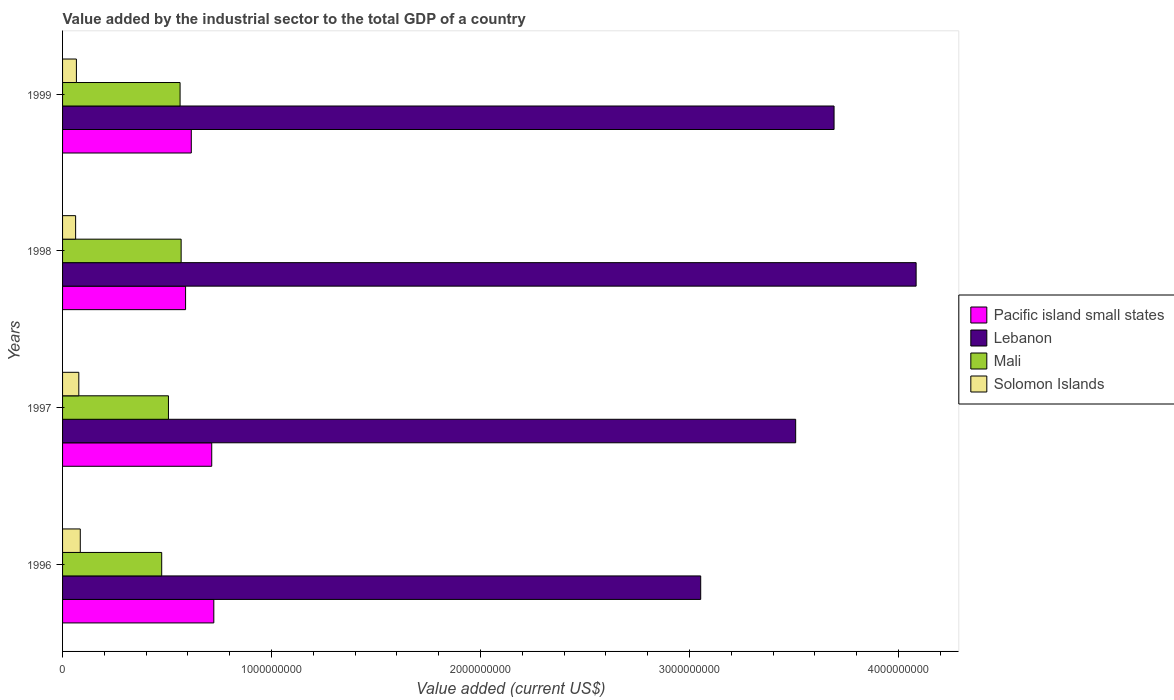Are the number of bars per tick equal to the number of legend labels?
Make the answer very short. Yes. How many bars are there on the 2nd tick from the bottom?
Offer a very short reply. 4. What is the value added by the industrial sector to the total GDP in Mali in 1996?
Your response must be concise. 4.74e+08. Across all years, what is the maximum value added by the industrial sector to the total GDP in Pacific island small states?
Keep it short and to the point. 7.24e+08. Across all years, what is the minimum value added by the industrial sector to the total GDP in Solomon Islands?
Your response must be concise. 6.25e+07. In which year was the value added by the industrial sector to the total GDP in Pacific island small states maximum?
Give a very brief answer. 1996. What is the total value added by the industrial sector to the total GDP in Solomon Islands in the graph?
Provide a succinct answer. 2.91e+08. What is the difference between the value added by the industrial sector to the total GDP in Mali in 1996 and that in 1998?
Offer a terse response. -9.30e+07. What is the difference between the value added by the industrial sector to the total GDP in Pacific island small states in 1996 and the value added by the industrial sector to the total GDP in Mali in 1999?
Your answer should be compact. 1.61e+08. What is the average value added by the industrial sector to the total GDP in Pacific island small states per year?
Keep it short and to the point. 6.61e+08. In the year 1999, what is the difference between the value added by the industrial sector to the total GDP in Mali and value added by the industrial sector to the total GDP in Solomon Islands?
Keep it short and to the point. 4.96e+08. In how many years, is the value added by the industrial sector to the total GDP in Mali greater than 2400000000 US$?
Make the answer very short. 0. What is the ratio of the value added by the industrial sector to the total GDP in Solomon Islands in 1996 to that in 1998?
Your response must be concise. 1.36. What is the difference between the highest and the second highest value added by the industrial sector to the total GDP in Pacific island small states?
Provide a short and direct response. 9.95e+06. What is the difference between the highest and the lowest value added by the industrial sector to the total GDP in Pacific island small states?
Your response must be concise. 1.35e+08. In how many years, is the value added by the industrial sector to the total GDP in Lebanon greater than the average value added by the industrial sector to the total GDP in Lebanon taken over all years?
Offer a terse response. 2. What does the 3rd bar from the top in 1999 represents?
Ensure brevity in your answer.  Lebanon. What does the 3rd bar from the bottom in 1996 represents?
Offer a very short reply. Mali. Are all the bars in the graph horizontal?
Make the answer very short. Yes. How many years are there in the graph?
Offer a terse response. 4. Does the graph contain any zero values?
Offer a terse response. No. Does the graph contain grids?
Your response must be concise. No. Where does the legend appear in the graph?
Ensure brevity in your answer.  Center right. How many legend labels are there?
Provide a short and direct response. 4. What is the title of the graph?
Ensure brevity in your answer.  Value added by the industrial sector to the total GDP of a country. Does "South Sudan" appear as one of the legend labels in the graph?
Your response must be concise. No. What is the label or title of the X-axis?
Offer a terse response. Value added (current US$). What is the label or title of the Y-axis?
Give a very brief answer. Years. What is the Value added (current US$) of Pacific island small states in 1996?
Offer a very short reply. 7.24e+08. What is the Value added (current US$) in Lebanon in 1996?
Your response must be concise. 3.05e+09. What is the Value added (current US$) in Mali in 1996?
Provide a short and direct response. 4.74e+08. What is the Value added (current US$) in Solomon Islands in 1996?
Your response must be concise. 8.48e+07. What is the Value added (current US$) in Pacific island small states in 1997?
Offer a terse response. 7.14e+08. What is the Value added (current US$) in Lebanon in 1997?
Ensure brevity in your answer.  3.51e+09. What is the Value added (current US$) in Mali in 1997?
Ensure brevity in your answer.  5.07e+08. What is the Value added (current US$) of Solomon Islands in 1997?
Make the answer very short. 7.77e+07. What is the Value added (current US$) in Pacific island small states in 1998?
Offer a very short reply. 5.89e+08. What is the Value added (current US$) in Lebanon in 1998?
Offer a terse response. 4.08e+09. What is the Value added (current US$) in Mali in 1998?
Keep it short and to the point. 5.67e+08. What is the Value added (current US$) in Solomon Islands in 1998?
Give a very brief answer. 6.25e+07. What is the Value added (current US$) in Pacific island small states in 1999?
Provide a short and direct response. 6.16e+08. What is the Value added (current US$) of Lebanon in 1999?
Your answer should be very brief. 3.69e+09. What is the Value added (current US$) in Mali in 1999?
Ensure brevity in your answer.  5.62e+08. What is the Value added (current US$) of Solomon Islands in 1999?
Offer a very short reply. 6.63e+07. Across all years, what is the maximum Value added (current US$) of Pacific island small states?
Offer a very short reply. 7.24e+08. Across all years, what is the maximum Value added (current US$) in Lebanon?
Give a very brief answer. 4.08e+09. Across all years, what is the maximum Value added (current US$) of Mali?
Offer a very short reply. 5.67e+08. Across all years, what is the maximum Value added (current US$) of Solomon Islands?
Provide a short and direct response. 8.48e+07. Across all years, what is the minimum Value added (current US$) of Pacific island small states?
Ensure brevity in your answer.  5.89e+08. Across all years, what is the minimum Value added (current US$) of Lebanon?
Offer a very short reply. 3.05e+09. Across all years, what is the minimum Value added (current US$) in Mali?
Make the answer very short. 4.74e+08. Across all years, what is the minimum Value added (current US$) in Solomon Islands?
Provide a succinct answer. 6.25e+07. What is the total Value added (current US$) of Pacific island small states in the graph?
Offer a very short reply. 2.64e+09. What is the total Value added (current US$) of Lebanon in the graph?
Provide a succinct answer. 1.43e+1. What is the total Value added (current US$) of Mali in the graph?
Ensure brevity in your answer.  2.11e+09. What is the total Value added (current US$) of Solomon Islands in the graph?
Make the answer very short. 2.91e+08. What is the difference between the Value added (current US$) of Pacific island small states in 1996 and that in 1997?
Provide a short and direct response. 9.95e+06. What is the difference between the Value added (current US$) in Lebanon in 1996 and that in 1997?
Give a very brief answer. -4.54e+08. What is the difference between the Value added (current US$) in Mali in 1996 and that in 1997?
Provide a short and direct response. -3.23e+07. What is the difference between the Value added (current US$) in Solomon Islands in 1996 and that in 1997?
Your answer should be very brief. 7.07e+06. What is the difference between the Value added (current US$) in Pacific island small states in 1996 and that in 1998?
Provide a succinct answer. 1.35e+08. What is the difference between the Value added (current US$) of Lebanon in 1996 and that in 1998?
Provide a short and direct response. -1.03e+09. What is the difference between the Value added (current US$) in Mali in 1996 and that in 1998?
Provide a short and direct response. -9.30e+07. What is the difference between the Value added (current US$) of Solomon Islands in 1996 and that in 1998?
Provide a succinct answer. 2.23e+07. What is the difference between the Value added (current US$) of Pacific island small states in 1996 and that in 1999?
Ensure brevity in your answer.  1.08e+08. What is the difference between the Value added (current US$) of Lebanon in 1996 and that in 1999?
Provide a short and direct response. -6.38e+08. What is the difference between the Value added (current US$) in Mali in 1996 and that in 1999?
Provide a succinct answer. -8.79e+07. What is the difference between the Value added (current US$) in Solomon Islands in 1996 and that in 1999?
Keep it short and to the point. 1.85e+07. What is the difference between the Value added (current US$) in Pacific island small states in 1997 and that in 1998?
Your response must be concise. 1.25e+08. What is the difference between the Value added (current US$) of Lebanon in 1997 and that in 1998?
Provide a succinct answer. -5.76e+08. What is the difference between the Value added (current US$) in Mali in 1997 and that in 1998?
Your answer should be compact. -6.07e+07. What is the difference between the Value added (current US$) of Solomon Islands in 1997 and that in 1998?
Provide a short and direct response. 1.53e+07. What is the difference between the Value added (current US$) of Pacific island small states in 1997 and that in 1999?
Make the answer very short. 9.78e+07. What is the difference between the Value added (current US$) in Lebanon in 1997 and that in 1999?
Ensure brevity in your answer.  -1.84e+08. What is the difference between the Value added (current US$) of Mali in 1997 and that in 1999?
Keep it short and to the point. -5.57e+07. What is the difference between the Value added (current US$) of Solomon Islands in 1997 and that in 1999?
Give a very brief answer. 1.15e+07. What is the difference between the Value added (current US$) of Pacific island small states in 1998 and that in 1999?
Make the answer very short. -2.74e+07. What is the difference between the Value added (current US$) of Lebanon in 1998 and that in 1999?
Make the answer very short. 3.93e+08. What is the difference between the Value added (current US$) in Mali in 1998 and that in 1999?
Make the answer very short. 5.05e+06. What is the difference between the Value added (current US$) of Solomon Islands in 1998 and that in 1999?
Your answer should be very brief. -3.80e+06. What is the difference between the Value added (current US$) of Pacific island small states in 1996 and the Value added (current US$) of Lebanon in 1997?
Your answer should be very brief. -2.78e+09. What is the difference between the Value added (current US$) of Pacific island small states in 1996 and the Value added (current US$) of Mali in 1997?
Your answer should be very brief. 2.17e+08. What is the difference between the Value added (current US$) of Pacific island small states in 1996 and the Value added (current US$) of Solomon Islands in 1997?
Make the answer very short. 6.46e+08. What is the difference between the Value added (current US$) of Lebanon in 1996 and the Value added (current US$) of Mali in 1997?
Keep it short and to the point. 2.55e+09. What is the difference between the Value added (current US$) of Lebanon in 1996 and the Value added (current US$) of Solomon Islands in 1997?
Offer a terse response. 2.98e+09. What is the difference between the Value added (current US$) of Mali in 1996 and the Value added (current US$) of Solomon Islands in 1997?
Ensure brevity in your answer.  3.97e+08. What is the difference between the Value added (current US$) in Pacific island small states in 1996 and the Value added (current US$) in Lebanon in 1998?
Keep it short and to the point. -3.36e+09. What is the difference between the Value added (current US$) of Pacific island small states in 1996 and the Value added (current US$) of Mali in 1998?
Give a very brief answer. 1.56e+08. What is the difference between the Value added (current US$) in Pacific island small states in 1996 and the Value added (current US$) in Solomon Islands in 1998?
Ensure brevity in your answer.  6.61e+08. What is the difference between the Value added (current US$) in Lebanon in 1996 and the Value added (current US$) in Mali in 1998?
Your response must be concise. 2.49e+09. What is the difference between the Value added (current US$) in Lebanon in 1996 and the Value added (current US$) in Solomon Islands in 1998?
Provide a succinct answer. 2.99e+09. What is the difference between the Value added (current US$) in Mali in 1996 and the Value added (current US$) in Solomon Islands in 1998?
Offer a very short reply. 4.12e+08. What is the difference between the Value added (current US$) of Pacific island small states in 1996 and the Value added (current US$) of Lebanon in 1999?
Provide a short and direct response. -2.97e+09. What is the difference between the Value added (current US$) of Pacific island small states in 1996 and the Value added (current US$) of Mali in 1999?
Give a very brief answer. 1.61e+08. What is the difference between the Value added (current US$) in Pacific island small states in 1996 and the Value added (current US$) in Solomon Islands in 1999?
Your answer should be very brief. 6.58e+08. What is the difference between the Value added (current US$) of Lebanon in 1996 and the Value added (current US$) of Mali in 1999?
Provide a succinct answer. 2.49e+09. What is the difference between the Value added (current US$) in Lebanon in 1996 and the Value added (current US$) in Solomon Islands in 1999?
Ensure brevity in your answer.  2.99e+09. What is the difference between the Value added (current US$) of Mali in 1996 and the Value added (current US$) of Solomon Islands in 1999?
Provide a short and direct response. 4.08e+08. What is the difference between the Value added (current US$) of Pacific island small states in 1997 and the Value added (current US$) of Lebanon in 1998?
Provide a succinct answer. -3.37e+09. What is the difference between the Value added (current US$) in Pacific island small states in 1997 and the Value added (current US$) in Mali in 1998?
Make the answer very short. 1.46e+08. What is the difference between the Value added (current US$) in Pacific island small states in 1997 and the Value added (current US$) in Solomon Islands in 1998?
Ensure brevity in your answer.  6.51e+08. What is the difference between the Value added (current US$) of Lebanon in 1997 and the Value added (current US$) of Mali in 1998?
Give a very brief answer. 2.94e+09. What is the difference between the Value added (current US$) in Lebanon in 1997 and the Value added (current US$) in Solomon Islands in 1998?
Your answer should be compact. 3.45e+09. What is the difference between the Value added (current US$) in Mali in 1997 and the Value added (current US$) in Solomon Islands in 1998?
Your answer should be compact. 4.44e+08. What is the difference between the Value added (current US$) in Pacific island small states in 1997 and the Value added (current US$) in Lebanon in 1999?
Ensure brevity in your answer.  -2.98e+09. What is the difference between the Value added (current US$) of Pacific island small states in 1997 and the Value added (current US$) of Mali in 1999?
Your response must be concise. 1.51e+08. What is the difference between the Value added (current US$) of Pacific island small states in 1997 and the Value added (current US$) of Solomon Islands in 1999?
Your answer should be compact. 6.48e+08. What is the difference between the Value added (current US$) in Lebanon in 1997 and the Value added (current US$) in Mali in 1999?
Make the answer very short. 2.95e+09. What is the difference between the Value added (current US$) of Lebanon in 1997 and the Value added (current US$) of Solomon Islands in 1999?
Provide a succinct answer. 3.44e+09. What is the difference between the Value added (current US$) of Mali in 1997 and the Value added (current US$) of Solomon Islands in 1999?
Offer a very short reply. 4.40e+08. What is the difference between the Value added (current US$) in Pacific island small states in 1998 and the Value added (current US$) in Lebanon in 1999?
Offer a very short reply. -3.10e+09. What is the difference between the Value added (current US$) in Pacific island small states in 1998 and the Value added (current US$) in Mali in 1999?
Make the answer very short. 2.63e+07. What is the difference between the Value added (current US$) of Pacific island small states in 1998 and the Value added (current US$) of Solomon Islands in 1999?
Ensure brevity in your answer.  5.22e+08. What is the difference between the Value added (current US$) of Lebanon in 1998 and the Value added (current US$) of Mali in 1999?
Offer a very short reply. 3.52e+09. What is the difference between the Value added (current US$) in Lebanon in 1998 and the Value added (current US$) in Solomon Islands in 1999?
Provide a short and direct response. 4.02e+09. What is the difference between the Value added (current US$) of Mali in 1998 and the Value added (current US$) of Solomon Islands in 1999?
Your answer should be very brief. 5.01e+08. What is the average Value added (current US$) in Pacific island small states per year?
Offer a terse response. 6.61e+08. What is the average Value added (current US$) of Lebanon per year?
Provide a short and direct response. 3.58e+09. What is the average Value added (current US$) in Mali per year?
Give a very brief answer. 5.28e+08. What is the average Value added (current US$) of Solomon Islands per year?
Your response must be concise. 7.28e+07. In the year 1996, what is the difference between the Value added (current US$) in Pacific island small states and Value added (current US$) in Lebanon?
Offer a terse response. -2.33e+09. In the year 1996, what is the difference between the Value added (current US$) in Pacific island small states and Value added (current US$) in Mali?
Keep it short and to the point. 2.49e+08. In the year 1996, what is the difference between the Value added (current US$) of Pacific island small states and Value added (current US$) of Solomon Islands?
Make the answer very short. 6.39e+08. In the year 1996, what is the difference between the Value added (current US$) in Lebanon and Value added (current US$) in Mali?
Offer a very short reply. 2.58e+09. In the year 1996, what is the difference between the Value added (current US$) in Lebanon and Value added (current US$) in Solomon Islands?
Your answer should be very brief. 2.97e+09. In the year 1996, what is the difference between the Value added (current US$) in Mali and Value added (current US$) in Solomon Islands?
Provide a succinct answer. 3.90e+08. In the year 1997, what is the difference between the Value added (current US$) of Pacific island small states and Value added (current US$) of Lebanon?
Make the answer very short. -2.79e+09. In the year 1997, what is the difference between the Value added (current US$) in Pacific island small states and Value added (current US$) in Mali?
Give a very brief answer. 2.07e+08. In the year 1997, what is the difference between the Value added (current US$) in Pacific island small states and Value added (current US$) in Solomon Islands?
Offer a terse response. 6.36e+08. In the year 1997, what is the difference between the Value added (current US$) of Lebanon and Value added (current US$) of Mali?
Your answer should be very brief. 3.00e+09. In the year 1997, what is the difference between the Value added (current US$) of Lebanon and Value added (current US$) of Solomon Islands?
Keep it short and to the point. 3.43e+09. In the year 1997, what is the difference between the Value added (current US$) in Mali and Value added (current US$) in Solomon Islands?
Provide a succinct answer. 4.29e+08. In the year 1998, what is the difference between the Value added (current US$) of Pacific island small states and Value added (current US$) of Lebanon?
Provide a short and direct response. -3.50e+09. In the year 1998, what is the difference between the Value added (current US$) of Pacific island small states and Value added (current US$) of Mali?
Ensure brevity in your answer.  2.12e+07. In the year 1998, what is the difference between the Value added (current US$) of Pacific island small states and Value added (current US$) of Solomon Islands?
Provide a short and direct response. 5.26e+08. In the year 1998, what is the difference between the Value added (current US$) in Lebanon and Value added (current US$) in Mali?
Offer a terse response. 3.52e+09. In the year 1998, what is the difference between the Value added (current US$) in Lebanon and Value added (current US$) in Solomon Islands?
Your answer should be very brief. 4.02e+09. In the year 1998, what is the difference between the Value added (current US$) in Mali and Value added (current US$) in Solomon Islands?
Offer a terse response. 5.05e+08. In the year 1999, what is the difference between the Value added (current US$) in Pacific island small states and Value added (current US$) in Lebanon?
Make the answer very short. -3.08e+09. In the year 1999, what is the difference between the Value added (current US$) of Pacific island small states and Value added (current US$) of Mali?
Offer a terse response. 5.37e+07. In the year 1999, what is the difference between the Value added (current US$) of Pacific island small states and Value added (current US$) of Solomon Islands?
Keep it short and to the point. 5.50e+08. In the year 1999, what is the difference between the Value added (current US$) of Lebanon and Value added (current US$) of Mali?
Ensure brevity in your answer.  3.13e+09. In the year 1999, what is the difference between the Value added (current US$) in Lebanon and Value added (current US$) in Solomon Islands?
Your response must be concise. 3.63e+09. In the year 1999, what is the difference between the Value added (current US$) in Mali and Value added (current US$) in Solomon Islands?
Your answer should be compact. 4.96e+08. What is the ratio of the Value added (current US$) of Pacific island small states in 1996 to that in 1997?
Provide a succinct answer. 1.01. What is the ratio of the Value added (current US$) of Lebanon in 1996 to that in 1997?
Your answer should be very brief. 0.87. What is the ratio of the Value added (current US$) of Mali in 1996 to that in 1997?
Your answer should be compact. 0.94. What is the ratio of the Value added (current US$) of Pacific island small states in 1996 to that in 1998?
Give a very brief answer. 1.23. What is the ratio of the Value added (current US$) in Lebanon in 1996 to that in 1998?
Your answer should be compact. 0.75. What is the ratio of the Value added (current US$) in Mali in 1996 to that in 1998?
Your response must be concise. 0.84. What is the ratio of the Value added (current US$) of Solomon Islands in 1996 to that in 1998?
Offer a terse response. 1.36. What is the ratio of the Value added (current US$) in Pacific island small states in 1996 to that in 1999?
Ensure brevity in your answer.  1.17. What is the ratio of the Value added (current US$) in Lebanon in 1996 to that in 1999?
Ensure brevity in your answer.  0.83. What is the ratio of the Value added (current US$) in Mali in 1996 to that in 1999?
Your response must be concise. 0.84. What is the ratio of the Value added (current US$) in Solomon Islands in 1996 to that in 1999?
Ensure brevity in your answer.  1.28. What is the ratio of the Value added (current US$) of Pacific island small states in 1997 to that in 1998?
Offer a terse response. 1.21. What is the ratio of the Value added (current US$) in Lebanon in 1997 to that in 1998?
Your answer should be very brief. 0.86. What is the ratio of the Value added (current US$) in Mali in 1997 to that in 1998?
Offer a terse response. 0.89. What is the ratio of the Value added (current US$) of Solomon Islands in 1997 to that in 1998?
Ensure brevity in your answer.  1.24. What is the ratio of the Value added (current US$) in Pacific island small states in 1997 to that in 1999?
Your answer should be very brief. 1.16. What is the ratio of the Value added (current US$) of Lebanon in 1997 to that in 1999?
Your answer should be very brief. 0.95. What is the ratio of the Value added (current US$) in Mali in 1997 to that in 1999?
Give a very brief answer. 0.9. What is the ratio of the Value added (current US$) in Solomon Islands in 1997 to that in 1999?
Your response must be concise. 1.17. What is the ratio of the Value added (current US$) in Pacific island small states in 1998 to that in 1999?
Your answer should be very brief. 0.96. What is the ratio of the Value added (current US$) of Lebanon in 1998 to that in 1999?
Make the answer very short. 1.11. What is the ratio of the Value added (current US$) in Solomon Islands in 1998 to that in 1999?
Your response must be concise. 0.94. What is the difference between the highest and the second highest Value added (current US$) of Pacific island small states?
Your answer should be very brief. 9.95e+06. What is the difference between the highest and the second highest Value added (current US$) in Lebanon?
Give a very brief answer. 3.93e+08. What is the difference between the highest and the second highest Value added (current US$) of Mali?
Provide a succinct answer. 5.05e+06. What is the difference between the highest and the second highest Value added (current US$) of Solomon Islands?
Provide a succinct answer. 7.07e+06. What is the difference between the highest and the lowest Value added (current US$) of Pacific island small states?
Keep it short and to the point. 1.35e+08. What is the difference between the highest and the lowest Value added (current US$) in Lebanon?
Offer a very short reply. 1.03e+09. What is the difference between the highest and the lowest Value added (current US$) in Mali?
Provide a succinct answer. 9.30e+07. What is the difference between the highest and the lowest Value added (current US$) in Solomon Islands?
Your answer should be very brief. 2.23e+07. 